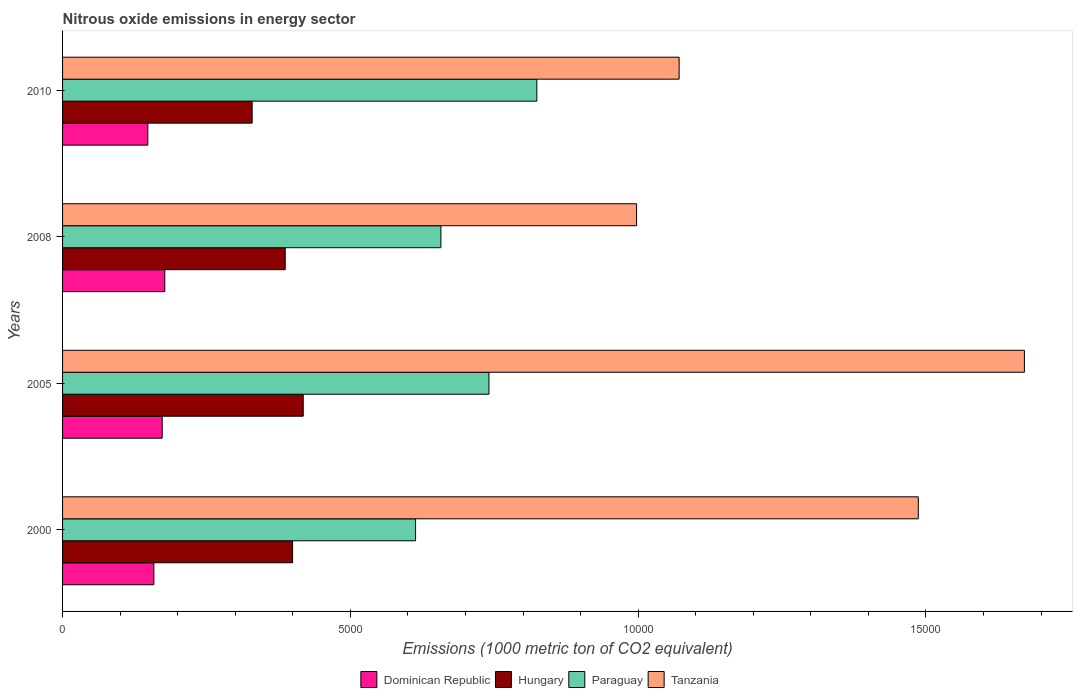How many different coloured bars are there?
Your response must be concise. 4. How many groups of bars are there?
Provide a short and direct response. 4. Are the number of bars per tick equal to the number of legend labels?
Make the answer very short. Yes. Are the number of bars on each tick of the Y-axis equal?
Give a very brief answer. Yes. How many bars are there on the 1st tick from the bottom?
Provide a succinct answer. 4. What is the label of the 2nd group of bars from the top?
Make the answer very short. 2008. What is the amount of nitrous oxide emitted in Tanzania in 2010?
Your response must be concise. 1.07e+04. Across all years, what is the maximum amount of nitrous oxide emitted in Dominican Republic?
Your response must be concise. 1775.7. Across all years, what is the minimum amount of nitrous oxide emitted in Hungary?
Keep it short and to the point. 3293.7. What is the total amount of nitrous oxide emitted in Hungary in the graph?
Give a very brief answer. 1.53e+04. What is the difference between the amount of nitrous oxide emitted in Dominican Republic in 2000 and that in 2005?
Make the answer very short. -144.6. What is the difference between the amount of nitrous oxide emitted in Hungary in 2010 and the amount of nitrous oxide emitted in Tanzania in 2000?
Make the answer very short. -1.16e+04. What is the average amount of nitrous oxide emitted in Dominican Republic per year?
Your answer should be very brief. 1643.65. In the year 2008, what is the difference between the amount of nitrous oxide emitted in Tanzania and amount of nitrous oxide emitted in Dominican Republic?
Keep it short and to the point. 8196.2. In how many years, is the amount of nitrous oxide emitted in Paraguay greater than 8000 1000 metric ton?
Your answer should be very brief. 1. What is the ratio of the amount of nitrous oxide emitted in Tanzania in 2008 to that in 2010?
Provide a succinct answer. 0.93. What is the difference between the highest and the second highest amount of nitrous oxide emitted in Hungary?
Your response must be concise. 184.9. What is the difference between the highest and the lowest amount of nitrous oxide emitted in Paraguay?
Offer a terse response. 2106.8. In how many years, is the amount of nitrous oxide emitted in Tanzania greater than the average amount of nitrous oxide emitted in Tanzania taken over all years?
Ensure brevity in your answer.  2. What does the 4th bar from the top in 2008 represents?
Your response must be concise. Dominican Republic. What does the 4th bar from the bottom in 2000 represents?
Provide a short and direct response. Tanzania. Is it the case that in every year, the sum of the amount of nitrous oxide emitted in Paraguay and amount of nitrous oxide emitted in Tanzania is greater than the amount of nitrous oxide emitted in Dominican Republic?
Your answer should be compact. Yes. How many bars are there?
Your answer should be very brief. 16. Are all the bars in the graph horizontal?
Your answer should be very brief. Yes. How many years are there in the graph?
Make the answer very short. 4. Are the values on the major ticks of X-axis written in scientific E-notation?
Offer a terse response. No. Does the graph contain grids?
Provide a short and direct response. No. How are the legend labels stacked?
Keep it short and to the point. Horizontal. What is the title of the graph?
Provide a short and direct response. Nitrous oxide emissions in energy sector. What is the label or title of the X-axis?
Make the answer very short. Emissions (1000 metric ton of CO2 equivalent). What is the Emissions (1000 metric ton of CO2 equivalent) in Dominican Republic in 2000?
Offer a terse response. 1586.4. What is the Emissions (1000 metric ton of CO2 equivalent) of Hungary in 2000?
Ensure brevity in your answer.  3996.3. What is the Emissions (1000 metric ton of CO2 equivalent) in Paraguay in 2000?
Give a very brief answer. 6132.8. What is the Emissions (1000 metric ton of CO2 equivalent) in Tanzania in 2000?
Your answer should be compact. 1.49e+04. What is the Emissions (1000 metric ton of CO2 equivalent) of Dominican Republic in 2005?
Offer a very short reply. 1731. What is the Emissions (1000 metric ton of CO2 equivalent) of Hungary in 2005?
Provide a short and direct response. 4181.2. What is the Emissions (1000 metric ton of CO2 equivalent) of Paraguay in 2005?
Give a very brief answer. 7407.7. What is the Emissions (1000 metric ton of CO2 equivalent) in Tanzania in 2005?
Your response must be concise. 1.67e+04. What is the Emissions (1000 metric ton of CO2 equivalent) of Dominican Republic in 2008?
Ensure brevity in your answer.  1775.7. What is the Emissions (1000 metric ton of CO2 equivalent) in Hungary in 2008?
Provide a succinct answer. 3868. What is the Emissions (1000 metric ton of CO2 equivalent) of Paraguay in 2008?
Offer a very short reply. 6573. What is the Emissions (1000 metric ton of CO2 equivalent) of Tanzania in 2008?
Provide a succinct answer. 9971.9. What is the Emissions (1000 metric ton of CO2 equivalent) of Dominican Republic in 2010?
Make the answer very short. 1481.5. What is the Emissions (1000 metric ton of CO2 equivalent) in Hungary in 2010?
Provide a succinct answer. 3293.7. What is the Emissions (1000 metric ton of CO2 equivalent) of Paraguay in 2010?
Give a very brief answer. 8239.6. What is the Emissions (1000 metric ton of CO2 equivalent) in Tanzania in 2010?
Ensure brevity in your answer.  1.07e+04. Across all years, what is the maximum Emissions (1000 metric ton of CO2 equivalent) of Dominican Republic?
Offer a very short reply. 1775.7. Across all years, what is the maximum Emissions (1000 metric ton of CO2 equivalent) of Hungary?
Keep it short and to the point. 4181.2. Across all years, what is the maximum Emissions (1000 metric ton of CO2 equivalent) of Paraguay?
Offer a very short reply. 8239.6. Across all years, what is the maximum Emissions (1000 metric ton of CO2 equivalent) of Tanzania?
Ensure brevity in your answer.  1.67e+04. Across all years, what is the minimum Emissions (1000 metric ton of CO2 equivalent) of Dominican Republic?
Your response must be concise. 1481.5. Across all years, what is the minimum Emissions (1000 metric ton of CO2 equivalent) of Hungary?
Provide a short and direct response. 3293.7. Across all years, what is the minimum Emissions (1000 metric ton of CO2 equivalent) in Paraguay?
Provide a succinct answer. 6132.8. Across all years, what is the minimum Emissions (1000 metric ton of CO2 equivalent) in Tanzania?
Ensure brevity in your answer.  9971.9. What is the total Emissions (1000 metric ton of CO2 equivalent) of Dominican Republic in the graph?
Offer a terse response. 6574.6. What is the total Emissions (1000 metric ton of CO2 equivalent) of Hungary in the graph?
Your response must be concise. 1.53e+04. What is the total Emissions (1000 metric ton of CO2 equivalent) of Paraguay in the graph?
Make the answer very short. 2.84e+04. What is the total Emissions (1000 metric ton of CO2 equivalent) in Tanzania in the graph?
Keep it short and to the point. 5.23e+04. What is the difference between the Emissions (1000 metric ton of CO2 equivalent) in Dominican Republic in 2000 and that in 2005?
Your answer should be very brief. -144.6. What is the difference between the Emissions (1000 metric ton of CO2 equivalent) in Hungary in 2000 and that in 2005?
Make the answer very short. -184.9. What is the difference between the Emissions (1000 metric ton of CO2 equivalent) in Paraguay in 2000 and that in 2005?
Give a very brief answer. -1274.9. What is the difference between the Emissions (1000 metric ton of CO2 equivalent) of Tanzania in 2000 and that in 2005?
Keep it short and to the point. -1843.1. What is the difference between the Emissions (1000 metric ton of CO2 equivalent) of Dominican Republic in 2000 and that in 2008?
Make the answer very short. -189.3. What is the difference between the Emissions (1000 metric ton of CO2 equivalent) of Hungary in 2000 and that in 2008?
Ensure brevity in your answer.  128.3. What is the difference between the Emissions (1000 metric ton of CO2 equivalent) in Paraguay in 2000 and that in 2008?
Keep it short and to the point. -440.2. What is the difference between the Emissions (1000 metric ton of CO2 equivalent) in Tanzania in 2000 and that in 2008?
Keep it short and to the point. 4894.9. What is the difference between the Emissions (1000 metric ton of CO2 equivalent) in Dominican Republic in 2000 and that in 2010?
Your response must be concise. 104.9. What is the difference between the Emissions (1000 metric ton of CO2 equivalent) in Hungary in 2000 and that in 2010?
Make the answer very short. 702.6. What is the difference between the Emissions (1000 metric ton of CO2 equivalent) in Paraguay in 2000 and that in 2010?
Your answer should be very brief. -2106.8. What is the difference between the Emissions (1000 metric ton of CO2 equivalent) of Tanzania in 2000 and that in 2010?
Offer a terse response. 4155. What is the difference between the Emissions (1000 metric ton of CO2 equivalent) of Dominican Republic in 2005 and that in 2008?
Your response must be concise. -44.7. What is the difference between the Emissions (1000 metric ton of CO2 equivalent) of Hungary in 2005 and that in 2008?
Your response must be concise. 313.2. What is the difference between the Emissions (1000 metric ton of CO2 equivalent) of Paraguay in 2005 and that in 2008?
Your answer should be compact. 834.7. What is the difference between the Emissions (1000 metric ton of CO2 equivalent) in Tanzania in 2005 and that in 2008?
Offer a very short reply. 6738. What is the difference between the Emissions (1000 metric ton of CO2 equivalent) in Dominican Republic in 2005 and that in 2010?
Provide a short and direct response. 249.5. What is the difference between the Emissions (1000 metric ton of CO2 equivalent) of Hungary in 2005 and that in 2010?
Your answer should be very brief. 887.5. What is the difference between the Emissions (1000 metric ton of CO2 equivalent) of Paraguay in 2005 and that in 2010?
Provide a short and direct response. -831.9. What is the difference between the Emissions (1000 metric ton of CO2 equivalent) in Tanzania in 2005 and that in 2010?
Your answer should be very brief. 5998.1. What is the difference between the Emissions (1000 metric ton of CO2 equivalent) in Dominican Republic in 2008 and that in 2010?
Keep it short and to the point. 294.2. What is the difference between the Emissions (1000 metric ton of CO2 equivalent) of Hungary in 2008 and that in 2010?
Your answer should be very brief. 574.3. What is the difference between the Emissions (1000 metric ton of CO2 equivalent) of Paraguay in 2008 and that in 2010?
Offer a terse response. -1666.6. What is the difference between the Emissions (1000 metric ton of CO2 equivalent) of Tanzania in 2008 and that in 2010?
Your response must be concise. -739.9. What is the difference between the Emissions (1000 metric ton of CO2 equivalent) of Dominican Republic in 2000 and the Emissions (1000 metric ton of CO2 equivalent) of Hungary in 2005?
Your response must be concise. -2594.8. What is the difference between the Emissions (1000 metric ton of CO2 equivalent) of Dominican Republic in 2000 and the Emissions (1000 metric ton of CO2 equivalent) of Paraguay in 2005?
Your answer should be very brief. -5821.3. What is the difference between the Emissions (1000 metric ton of CO2 equivalent) in Dominican Republic in 2000 and the Emissions (1000 metric ton of CO2 equivalent) in Tanzania in 2005?
Offer a terse response. -1.51e+04. What is the difference between the Emissions (1000 metric ton of CO2 equivalent) in Hungary in 2000 and the Emissions (1000 metric ton of CO2 equivalent) in Paraguay in 2005?
Give a very brief answer. -3411.4. What is the difference between the Emissions (1000 metric ton of CO2 equivalent) in Hungary in 2000 and the Emissions (1000 metric ton of CO2 equivalent) in Tanzania in 2005?
Offer a terse response. -1.27e+04. What is the difference between the Emissions (1000 metric ton of CO2 equivalent) of Paraguay in 2000 and the Emissions (1000 metric ton of CO2 equivalent) of Tanzania in 2005?
Ensure brevity in your answer.  -1.06e+04. What is the difference between the Emissions (1000 metric ton of CO2 equivalent) in Dominican Republic in 2000 and the Emissions (1000 metric ton of CO2 equivalent) in Hungary in 2008?
Offer a terse response. -2281.6. What is the difference between the Emissions (1000 metric ton of CO2 equivalent) in Dominican Republic in 2000 and the Emissions (1000 metric ton of CO2 equivalent) in Paraguay in 2008?
Keep it short and to the point. -4986.6. What is the difference between the Emissions (1000 metric ton of CO2 equivalent) of Dominican Republic in 2000 and the Emissions (1000 metric ton of CO2 equivalent) of Tanzania in 2008?
Provide a succinct answer. -8385.5. What is the difference between the Emissions (1000 metric ton of CO2 equivalent) of Hungary in 2000 and the Emissions (1000 metric ton of CO2 equivalent) of Paraguay in 2008?
Offer a terse response. -2576.7. What is the difference between the Emissions (1000 metric ton of CO2 equivalent) of Hungary in 2000 and the Emissions (1000 metric ton of CO2 equivalent) of Tanzania in 2008?
Give a very brief answer. -5975.6. What is the difference between the Emissions (1000 metric ton of CO2 equivalent) in Paraguay in 2000 and the Emissions (1000 metric ton of CO2 equivalent) in Tanzania in 2008?
Your answer should be compact. -3839.1. What is the difference between the Emissions (1000 metric ton of CO2 equivalent) of Dominican Republic in 2000 and the Emissions (1000 metric ton of CO2 equivalent) of Hungary in 2010?
Provide a short and direct response. -1707.3. What is the difference between the Emissions (1000 metric ton of CO2 equivalent) of Dominican Republic in 2000 and the Emissions (1000 metric ton of CO2 equivalent) of Paraguay in 2010?
Your answer should be compact. -6653.2. What is the difference between the Emissions (1000 metric ton of CO2 equivalent) of Dominican Republic in 2000 and the Emissions (1000 metric ton of CO2 equivalent) of Tanzania in 2010?
Give a very brief answer. -9125.4. What is the difference between the Emissions (1000 metric ton of CO2 equivalent) of Hungary in 2000 and the Emissions (1000 metric ton of CO2 equivalent) of Paraguay in 2010?
Keep it short and to the point. -4243.3. What is the difference between the Emissions (1000 metric ton of CO2 equivalent) of Hungary in 2000 and the Emissions (1000 metric ton of CO2 equivalent) of Tanzania in 2010?
Give a very brief answer. -6715.5. What is the difference between the Emissions (1000 metric ton of CO2 equivalent) of Paraguay in 2000 and the Emissions (1000 metric ton of CO2 equivalent) of Tanzania in 2010?
Ensure brevity in your answer.  -4579. What is the difference between the Emissions (1000 metric ton of CO2 equivalent) in Dominican Republic in 2005 and the Emissions (1000 metric ton of CO2 equivalent) in Hungary in 2008?
Your response must be concise. -2137. What is the difference between the Emissions (1000 metric ton of CO2 equivalent) of Dominican Republic in 2005 and the Emissions (1000 metric ton of CO2 equivalent) of Paraguay in 2008?
Offer a very short reply. -4842. What is the difference between the Emissions (1000 metric ton of CO2 equivalent) in Dominican Republic in 2005 and the Emissions (1000 metric ton of CO2 equivalent) in Tanzania in 2008?
Offer a very short reply. -8240.9. What is the difference between the Emissions (1000 metric ton of CO2 equivalent) in Hungary in 2005 and the Emissions (1000 metric ton of CO2 equivalent) in Paraguay in 2008?
Give a very brief answer. -2391.8. What is the difference between the Emissions (1000 metric ton of CO2 equivalent) of Hungary in 2005 and the Emissions (1000 metric ton of CO2 equivalent) of Tanzania in 2008?
Your answer should be compact. -5790.7. What is the difference between the Emissions (1000 metric ton of CO2 equivalent) of Paraguay in 2005 and the Emissions (1000 metric ton of CO2 equivalent) of Tanzania in 2008?
Your answer should be compact. -2564.2. What is the difference between the Emissions (1000 metric ton of CO2 equivalent) in Dominican Republic in 2005 and the Emissions (1000 metric ton of CO2 equivalent) in Hungary in 2010?
Make the answer very short. -1562.7. What is the difference between the Emissions (1000 metric ton of CO2 equivalent) in Dominican Republic in 2005 and the Emissions (1000 metric ton of CO2 equivalent) in Paraguay in 2010?
Keep it short and to the point. -6508.6. What is the difference between the Emissions (1000 metric ton of CO2 equivalent) in Dominican Republic in 2005 and the Emissions (1000 metric ton of CO2 equivalent) in Tanzania in 2010?
Offer a very short reply. -8980.8. What is the difference between the Emissions (1000 metric ton of CO2 equivalent) of Hungary in 2005 and the Emissions (1000 metric ton of CO2 equivalent) of Paraguay in 2010?
Your answer should be compact. -4058.4. What is the difference between the Emissions (1000 metric ton of CO2 equivalent) in Hungary in 2005 and the Emissions (1000 metric ton of CO2 equivalent) in Tanzania in 2010?
Make the answer very short. -6530.6. What is the difference between the Emissions (1000 metric ton of CO2 equivalent) of Paraguay in 2005 and the Emissions (1000 metric ton of CO2 equivalent) of Tanzania in 2010?
Provide a succinct answer. -3304.1. What is the difference between the Emissions (1000 metric ton of CO2 equivalent) in Dominican Republic in 2008 and the Emissions (1000 metric ton of CO2 equivalent) in Hungary in 2010?
Your answer should be compact. -1518. What is the difference between the Emissions (1000 metric ton of CO2 equivalent) in Dominican Republic in 2008 and the Emissions (1000 metric ton of CO2 equivalent) in Paraguay in 2010?
Your answer should be compact. -6463.9. What is the difference between the Emissions (1000 metric ton of CO2 equivalent) of Dominican Republic in 2008 and the Emissions (1000 metric ton of CO2 equivalent) of Tanzania in 2010?
Offer a terse response. -8936.1. What is the difference between the Emissions (1000 metric ton of CO2 equivalent) of Hungary in 2008 and the Emissions (1000 metric ton of CO2 equivalent) of Paraguay in 2010?
Offer a very short reply. -4371.6. What is the difference between the Emissions (1000 metric ton of CO2 equivalent) in Hungary in 2008 and the Emissions (1000 metric ton of CO2 equivalent) in Tanzania in 2010?
Ensure brevity in your answer.  -6843.8. What is the difference between the Emissions (1000 metric ton of CO2 equivalent) in Paraguay in 2008 and the Emissions (1000 metric ton of CO2 equivalent) in Tanzania in 2010?
Make the answer very short. -4138.8. What is the average Emissions (1000 metric ton of CO2 equivalent) of Dominican Republic per year?
Provide a succinct answer. 1643.65. What is the average Emissions (1000 metric ton of CO2 equivalent) in Hungary per year?
Ensure brevity in your answer.  3834.8. What is the average Emissions (1000 metric ton of CO2 equivalent) in Paraguay per year?
Your answer should be very brief. 7088.27. What is the average Emissions (1000 metric ton of CO2 equivalent) of Tanzania per year?
Offer a very short reply. 1.31e+04. In the year 2000, what is the difference between the Emissions (1000 metric ton of CO2 equivalent) in Dominican Republic and Emissions (1000 metric ton of CO2 equivalent) in Hungary?
Keep it short and to the point. -2409.9. In the year 2000, what is the difference between the Emissions (1000 metric ton of CO2 equivalent) in Dominican Republic and Emissions (1000 metric ton of CO2 equivalent) in Paraguay?
Provide a succinct answer. -4546.4. In the year 2000, what is the difference between the Emissions (1000 metric ton of CO2 equivalent) in Dominican Republic and Emissions (1000 metric ton of CO2 equivalent) in Tanzania?
Give a very brief answer. -1.33e+04. In the year 2000, what is the difference between the Emissions (1000 metric ton of CO2 equivalent) in Hungary and Emissions (1000 metric ton of CO2 equivalent) in Paraguay?
Provide a succinct answer. -2136.5. In the year 2000, what is the difference between the Emissions (1000 metric ton of CO2 equivalent) of Hungary and Emissions (1000 metric ton of CO2 equivalent) of Tanzania?
Your response must be concise. -1.09e+04. In the year 2000, what is the difference between the Emissions (1000 metric ton of CO2 equivalent) of Paraguay and Emissions (1000 metric ton of CO2 equivalent) of Tanzania?
Your answer should be very brief. -8734. In the year 2005, what is the difference between the Emissions (1000 metric ton of CO2 equivalent) in Dominican Republic and Emissions (1000 metric ton of CO2 equivalent) in Hungary?
Your answer should be compact. -2450.2. In the year 2005, what is the difference between the Emissions (1000 metric ton of CO2 equivalent) of Dominican Republic and Emissions (1000 metric ton of CO2 equivalent) of Paraguay?
Provide a succinct answer. -5676.7. In the year 2005, what is the difference between the Emissions (1000 metric ton of CO2 equivalent) of Dominican Republic and Emissions (1000 metric ton of CO2 equivalent) of Tanzania?
Offer a very short reply. -1.50e+04. In the year 2005, what is the difference between the Emissions (1000 metric ton of CO2 equivalent) in Hungary and Emissions (1000 metric ton of CO2 equivalent) in Paraguay?
Provide a succinct answer. -3226.5. In the year 2005, what is the difference between the Emissions (1000 metric ton of CO2 equivalent) of Hungary and Emissions (1000 metric ton of CO2 equivalent) of Tanzania?
Offer a very short reply. -1.25e+04. In the year 2005, what is the difference between the Emissions (1000 metric ton of CO2 equivalent) of Paraguay and Emissions (1000 metric ton of CO2 equivalent) of Tanzania?
Your response must be concise. -9302.2. In the year 2008, what is the difference between the Emissions (1000 metric ton of CO2 equivalent) in Dominican Republic and Emissions (1000 metric ton of CO2 equivalent) in Hungary?
Make the answer very short. -2092.3. In the year 2008, what is the difference between the Emissions (1000 metric ton of CO2 equivalent) of Dominican Republic and Emissions (1000 metric ton of CO2 equivalent) of Paraguay?
Offer a terse response. -4797.3. In the year 2008, what is the difference between the Emissions (1000 metric ton of CO2 equivalent) of Dominican Republic and Emissions (1000 metric ton of CO2 equivalent) of Tanzania?
Your answer should be very brief. -8196.2. In the year 2008, what is the difference between the Emissions (1000 metric ton of CO2 equivalent) of Hungary and Emissions (1000 metric ton of CO2 equivalent) of Paraguay?
Keep it short and to the point. -2705. In the year 2008, what is the difference between the Emissions (1000 metric ton of CO2 equivalent) in Hungary and Emissions (1000 metric ton of CO2 equivalent) in Tanzania?
Offer a very short reply. -6103.9. In the year 2008, what is the difference between the Emissions (1000 metric ton of CO2 equivalent) in Paraguay and Emissions (1000 metric ton of CO2 equivalent) in Tanzania?
Make the answer very short. -3398.9. In the year 2010, what is the difference between the Emissions (1000 metric ton of CO2 equivalent) in Dominican Republic and Emissions (1000 metric ton of CO2 equivalent) in Hungary?
Offer a terse response. -1812.2. In the year 2010, what is the difference between the Emissions (1000 metric ton of CO2 equivalent) in Dominican Republic and Emissions (1000 metric ton of CO2 equivalent) in Paraguay?
Offer a very short reply. -6758.1. In the year 2010, what is the difference between the Emissions (1000 metric ton of CO2 equivalent) of Dominican Republic and Emissions (1000 metric ton of CO2 equivalent) of Tanzania?
Give a very brief answer. -9230.3. In the year 2010, what is the difference between the Emissions (1000 metric ton of CO2 equivalent) in Hungary and Emissions (1000 metric ton of CO2 equivalent) in Paraguay?
Make the answer very short. -4945.9. In the year 2010, what is the difference between the Emissions (1000 metric ton of CO2 equivalent) in Hungary and Emissions (1000 metric ton of CO2 equivalent) in Tanzania?
Your answer should be compact. -7418.1. In the year 2010, what is the difference between the Emissions (1000 metric ton of CO2 equivalent) of Paraguay and Emissions (1000 metric ton of CO2 equivalent) of Tanzania?
Provide a short and direct response. -2472.2. What is the ratio of the Emissions (1000 metric ton of CO2 equivalent) of Dominican Republic in 2000 to that in 2005?
Provide a short and direct response. 0.92. What is the ratio of the Emissions (1000 metric ton of CO2 equivalent) of Hungary in 2000 to that in 2005?
Provide a short and direct response. 0.96. What is the ratio of the Emissions (1000 metric ton of CO2 equivalent) of Paraguay in 2000 to that in 2005?
Your response must be concise. 0.83. What is the ratio of the Emissions (1000 metric ton of CO2 equivalent) of Tanzania in 2000 to that in 2005?
Make the answer very short. 0.89. What is the ratio of the Emissions (1000 metric ton of CO2 equivalent) in Dominican Republic in 2000 to that in 2008?
Provide a succinct answer. 0.89. What is the ratio of the Emissions (1000 metric ton of CO2 equivalent) of Hungary in 2000 to that in 2008?
Make the answer very short. 1.03. What is the ratio of the Emissions (1000 metric ton of CO2 equivalent) in Paraguay in 2000 to that in 2008?
Make the answer very short. 0.93. What is the ratio of the Emissions (1000 metric ton of CO2 equivalent) in Tanzania in 2000 to that in 2008?
Your response must be concise. 1.49. What is the ratio of the Emissions (1000 metric ton of CO2 equivalent) of Dominican Republic in 2000 to that in 2010?
Give a very brief answer. 1.07. What is the ratio of the Emissions (1000 metric ton of CO2 equivalent) of Hungary in 2000 to that in 2010?
Your answer should be very brief. 1.21. What is the ratio of the Emissions (1000 metric ton of CO2 equivalent) in Paraguay in 2000 to that in 2010?
Your response must be concise. 0.74. What is the ratio of the Emissions (1000 metric ton of CO2 equivalent) in Tanzania in 2000 to that in 2010?
Give a very brief answer. 1.39. What is the ratio of the Emissions (1000 metric ton of CO2 equivalent) of Dominican Republic in 2005 to that in 2008?
Give a very brief answer. 0.97. What is the ratio of the Emissions (1000 metric ton of CO2 equivalent) of Hungary in 2005 to that in 2008?
Make the answer very short. 1.08. What is the ratio of the Emissions (1000 metric ton of CO2 equivalent) of Paraguay in 2005 to that in 2008?
Ensure brevity in your answer.  1.13. What is the ratio of the Emissions (1000 metric ton of CO2 equivalent) in Tanzania in 2005 to that in 2008?
Give a very brief answer. 1.68. What is the ratio of the Emissions (1000 metric ton of CO2 equivalent) in Dominican Republic in 2005 to that in 2010?
Ensure brevity in your answer.  1.17. What is the ratio of the Emissions (1000 metric ton of CO2 equivalent) of Hungary in 2005 to that in 2010?
Provide a succinct answer. 1.27. What is the ratio of the Emissions (1000 metric ton of CO2 equivalent) of Paraguay in 2005 to that in 2010?
Your answer should be very brief. 0.9. What is the ratio of the Emissions (1000 metric ton of CO2 equivalent) in Tanzania in 2005 to that in 2010?
Make the answer very short. 1.56. What is the ratio of the Emissions (1000 metric ton of CO2 equivalent) of Dominican Republic in 2008 to that in 2010?
Give a very brief answer. 1.2. What is the ratio of the Emissions (1000 metric ton of CO2 equivalent) of Hungary in 2008 to that in 2010?
Offer a terse response. 1.17. What is the ratio of the Emissions (1000 metric ton of CO2 equivalent) of Paraguay in 2008 to that in 2010?
Give a very brief answer. 0.8. What is the ratio of the Emissions (1000 metric ton of CO2 equivalent) of Tanzania in 2008 to that in 2010?
Give a very brief answer. 0.93. What is the difference between the highest and the second highest Emissions (1000 metric ton of CO2 equivalent) of Dominican Republic?
Your response must be concise. 44.7. What is the difference between the highest and the second highest Emissions (1000 metric ton of CO2 equivalent) in Hungary?
Your answer should be compact. 184.9. What is the difference between the highest and the second highest Emissions (1000 metric ton of CO2 equivalent) of Paraguay?
Provide a short and direct response. 831.9. What is the difference between the highest and the second highest Emissions (1000 metric ton of CO2 equivalent) of Tanzania?
Your answer should be very brief. 1843.1. What is the difference between the highest and the lowest Emissions (1000 metric ton of CO2 equivalent) in Dominican Republic?
Offer a very short reply. 294.2. What is the difference between the highest and the lowest Emissions (1000 metric ton of CO2 equivalent) in Hungary?
Your response must be concise. 887.5. What is the difference between the highest and the lowest Emissions (1000 metric ton of CO2 equivalent) of Paraguay?
Your answer should be compact. 2106.8. What is the difference between the highest and the lowest Emissions (1000 metric ton of CO2 equivalent) in Tanzania?
Ensure brevity in your answer.  6738. 